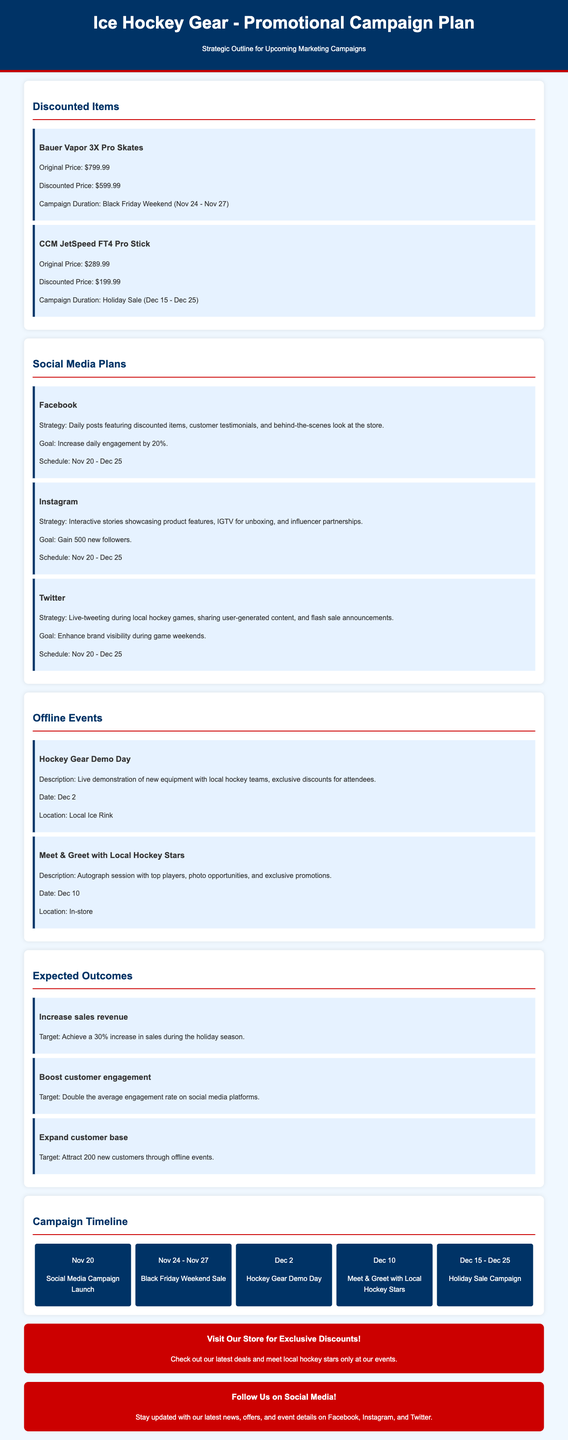What is the original price of Bauer Vapor 3X Pro Skates? The original price of Bauer Vapor 3X Pro Skates is listed in the document as $799.99.
Answer: $799.99 What is the discounted price of CCM JetSpeed FT4 Pro Stick? The discounted price for the CCM JetSpeed FT4 Pro Stick is specifically stated in the document as $199.99.
Answer: $199.99 When does the Holiday Sale campaign start? The document lists the beginning date of the Holiday Sale campaign as December 15.
Answer: December 15 What is the goal for the Instagram campaign? The document indicates that the goal for the Instagram campaign is to gain 500 new followers.
Answer: 500 new followers Where is the Hockey Gear Demo Day taking place? The document specifies that the location for the Hockey Gear Demo Day is the Local Ice Rink.
Answer: Local Ice Rink How much increase in sales revenue is targeted during the holiday season? The target increase in sales revenue during the holiday season is a 30% increase as stated in the document.
Answer: 30% What date is the Meet & Greet with Local Hockey Stars scheduled for? The document lists the date for the Meet & Greet with Local Hockey Stars as December 10.
Answer: December 10 What is the main strategy for Facebook in the campaign? According to the document, the main strategy for Facebook includes daily posts featuring discounted items.
Answer: Daily posts featuring discounted items What is the main purpose of the call-to-action in the document? The purpose of the call-to-action is to encourage visits to the store for exclusive discounts.
Answer: Encourage visits to the store for exclusive discounts 